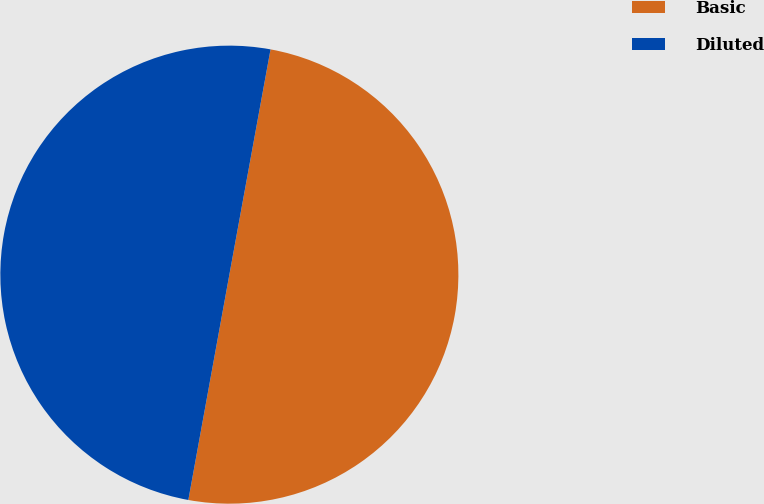Convert chart to OTSL. <chart><loc_0><loc_0><loc_500><loc_500><pie_chart><fcel>Basic<fcel>Diluted<nl><fcel>49.99%<fcel>50.01%<nl></chart> 